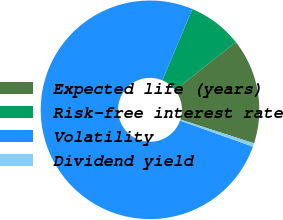<chart> <loc_0><loc_0><loc_500><loc_500><pie_chart><fcel>Expected life (years)<fcel>Risk-free interest rate<fcel>Volatility<fcel>Dividend yield<nl><fcel>15.58%<fcel>8.05%<fcel>75.85%<fcel>0.52%<nl></chart> 